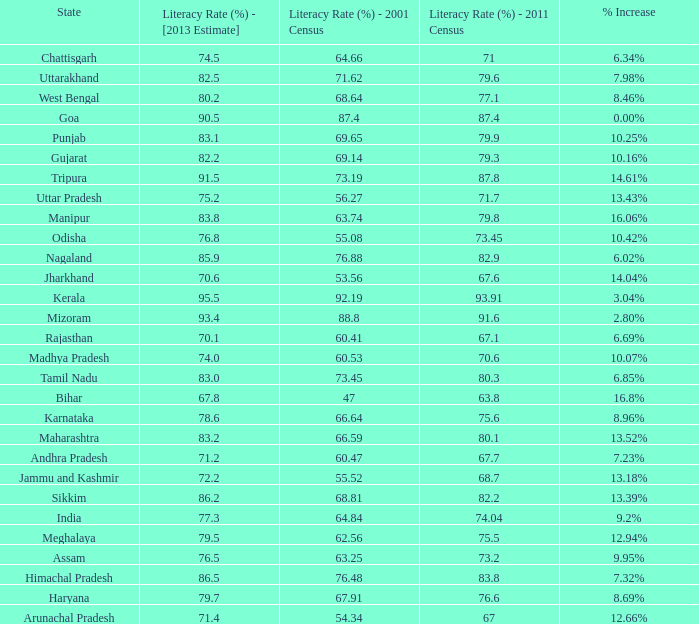What is the average increase in literacy for the states that had a rate higher than 73.2% in 2011, less than 68.81% in 2001, and an estimate of 76.8% for 2013? 10.42%. 